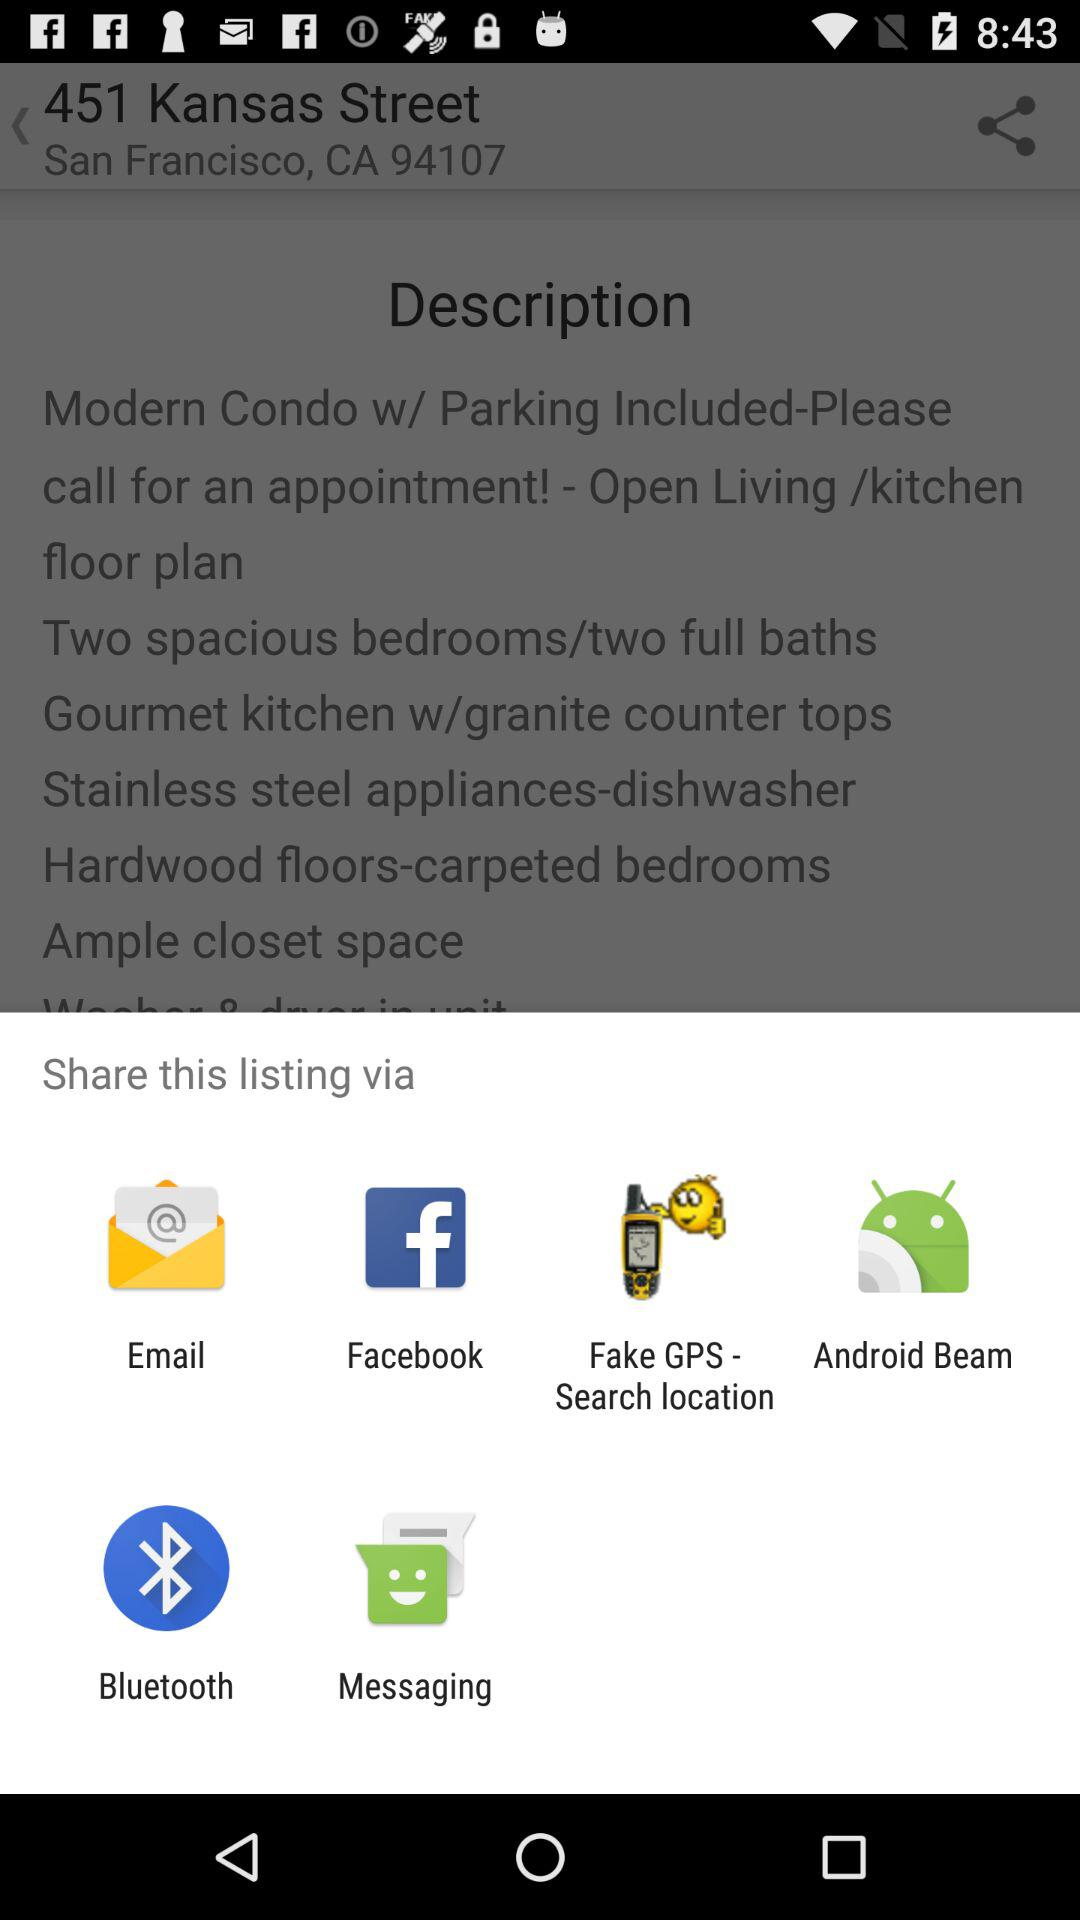What are the sharing options? The sharing options are "Email", "Facebook", "Fake GPS - Search location", "Android Beam", "Bluetooth" and "Messaging". 